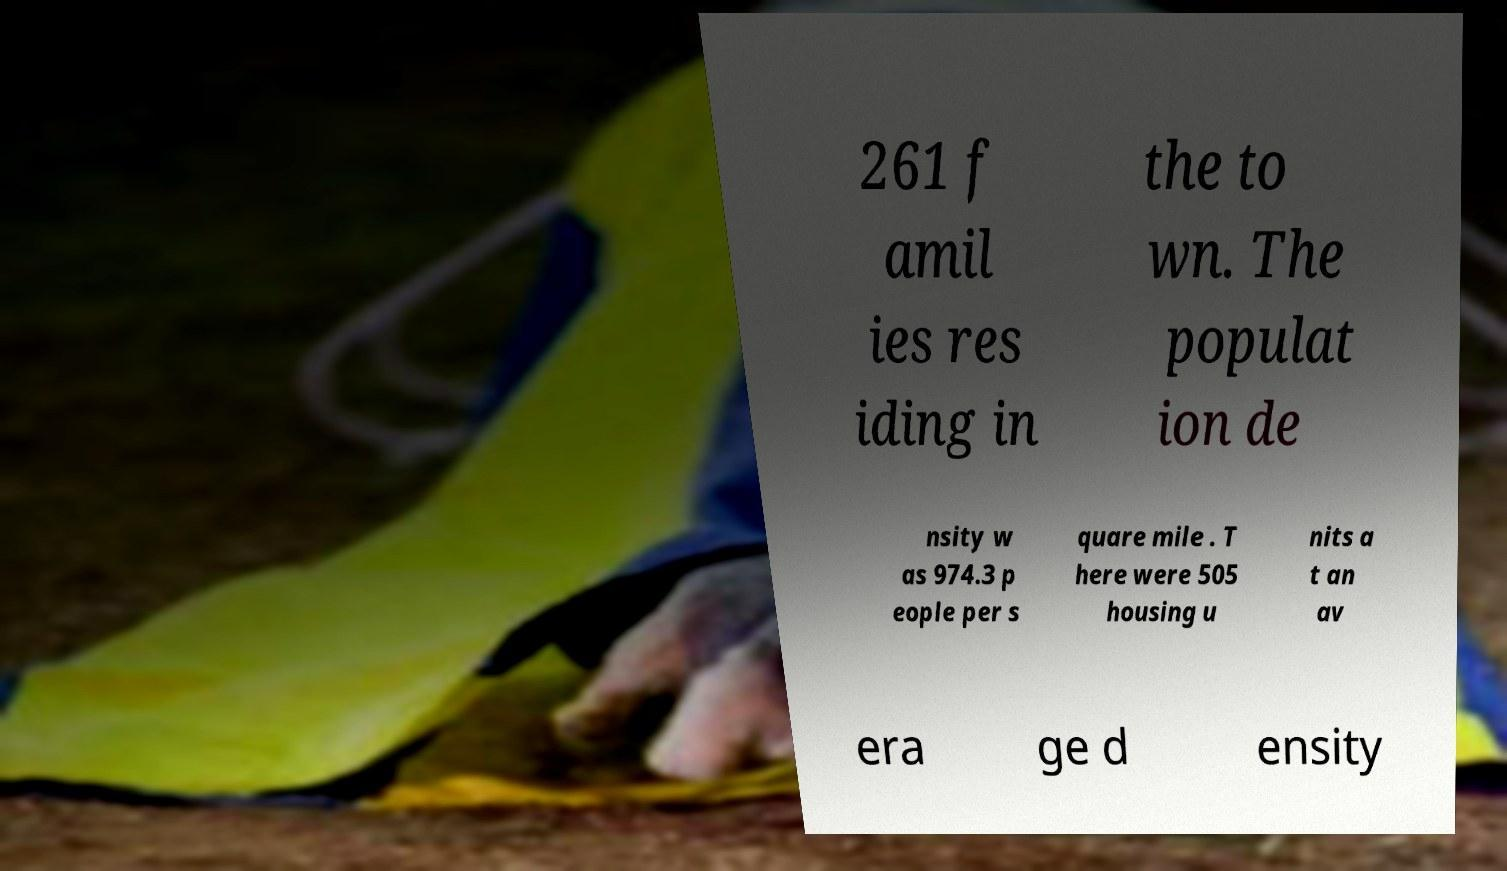Please read and relay the text visible in this image. What does it say? 261 f amil ies res iding in the to wn. The populat ion de nsity w as 974.3 p eople per s quare mile . T here were 505 housing u nits a t an av era ge d ensity 